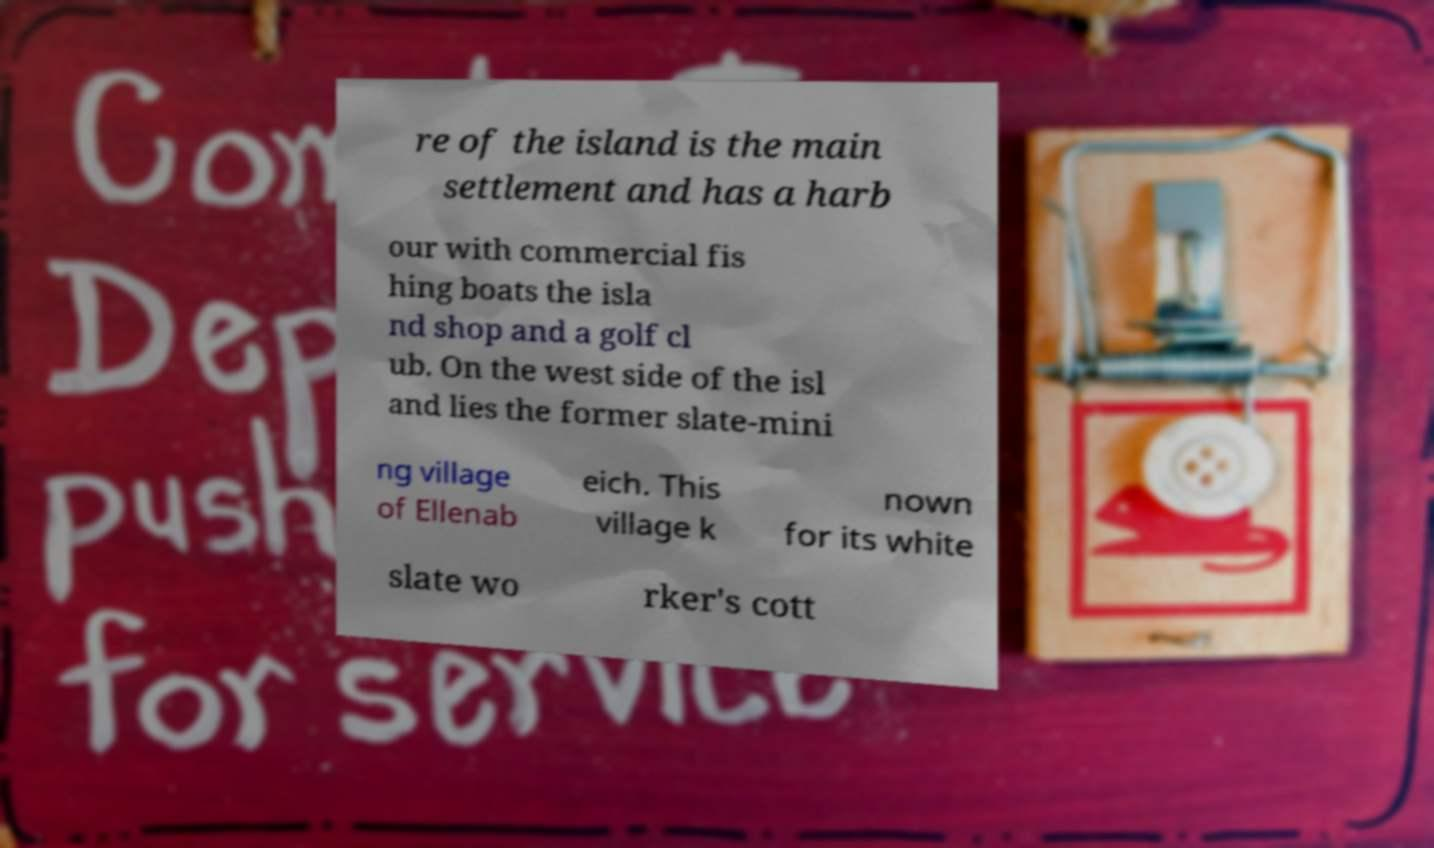What messages or text are displayed in this image? I need them in a readable, typed format. re of the island is the main settlement and has a harb our with commercial fis hing boats the isla nd shop and a golf cl ub. On the west side of the isl and lies the former slate-mini ng village of Ellenab eich. This village k nown for its white slate wo rker's cott 